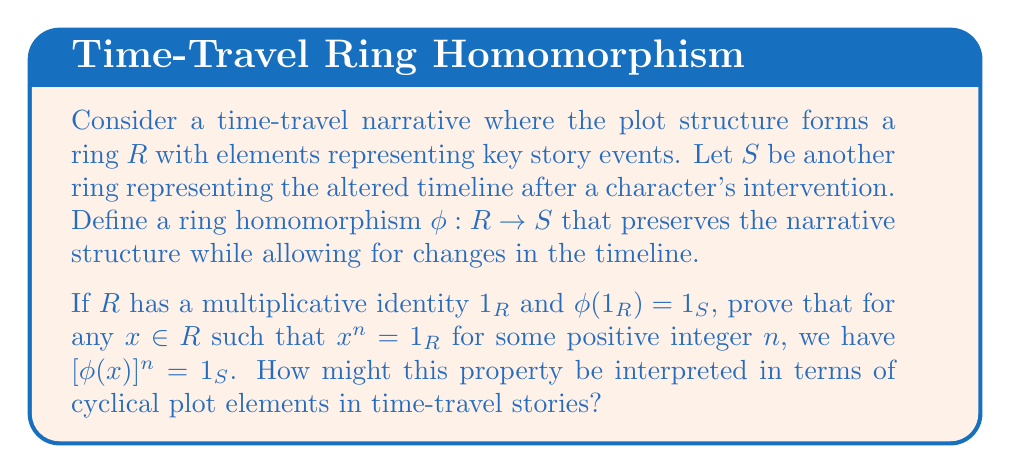Teach me how to tackle this problem. Let's approach this proof step by step:

1) First, recall that a ring homomorphism $\phi: R \rightarrow S$ preserves both addition and multiplication. That is, for any $a, b \in R$:
   
   $\phi(a + b) = \phi(a) + \phi(b)$
   $\phi(ab) = \phi(a)\phi(b)$

2) We're given that $\phi(1_R) = 1_S$, where $1_R$ and $1_S$ are the multiplicative identities in $R$ and $S$ respectively.

3) Now, let $x \in R$ such that $x^n = 1_R$ for some positive integer $n$.

4) We need to prove that $[\phi(x)]^n = 1_S$. Let's start by considering $\phi(x^n)$:

   $\phi(x^n) = \phi(x \cdot x \cdot ... \cdot x)$ (n times)

5) Using the multiplicative property of ring homomorphisms repeatedly, we get:

   $\phi(x^n) = \phi(x) \cdot \phi(x) \cdot ... \cdot \phi(x)$ (n times) $= [\phi(x)]^n$

6) But we know that $x^n = 1_R$, so:

   $\phi(x^n) = \phi(1_R)$

7) And we're given that $\phi(1_R) = 1_S$, so:

   $\phi(x^n) = 1_S$

8) Combining steps 5 and 7, we conclude:

   $[\phi(x)]^n = 1_S$

This property can be interpreted in terms of cyclical plot elements in time-travel stories as follows:

If an element $x$ in the original timeline $R$ represents a cyclical event (i.e., $x^n = 1_R$ for some n), then its corresponding event $\phi(x)$ in the altered timeline $S$ will also be cyclical with the same period. This could represent recurring plot points, time loops, or cyclic character arcs that persist even when the timeline is altered, maintaining the fundamental structure of the narrative despite changes in specific events.
Answer: $[\phi(x)]^n = 1_S$, where $x \in R$, $x^n = 1_R$, and $\phi: R \rightarrow S$ is a ring homomorphism with $\phi(1_R) = 1_S$. 